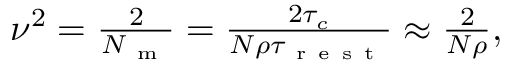<formula> <loc_0><loc_0><loc_500><loc_500>\begin{array} { r } { \nu ^ { 2 } = \frac { 2 } { N _ { m } } = \frac { 2 \tau _ { c } } { N \rho \tau _ { r e s t } } \approx \frac { 2 } { N \rho } , } \end{array}</formula> 